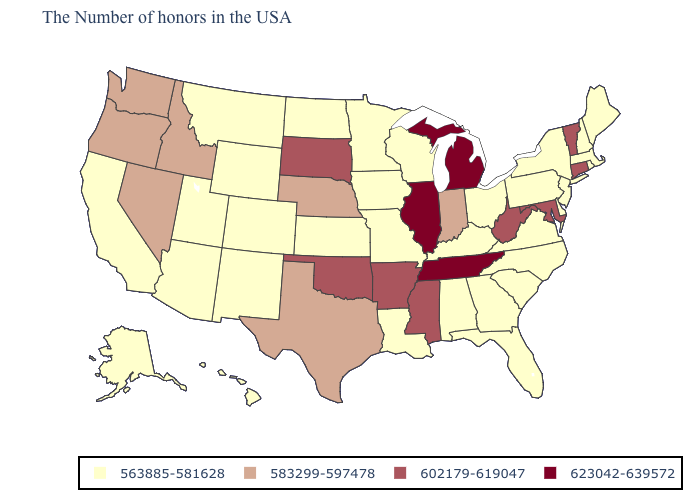Among the states that border Rhode Island , does Connecticut have the lowest value?
Give a very brief answer. No. What is the value of Michigan?
Give a very brief answer. 623042-639572. What is the value of Minnesota?
Quick response, please. 563885-581628. What is the value of South Dakota?
Answer briefly. 602179-619047. Name the states that have a value in the range 583299-597478?
Be succinct. Indiana, Nebraska, Texas, Idaho, Nevada, Washington, Oregon. Does Wyoming have the highest value in the West?
Keep it brief. No. Name the states that have a value in the range 623042-639572?
Give a very brief answer. Michigan, Tennessee, Illinois. Which states have the lowest value in the USA?
Short answer required. Maine, Massachusetts, Rhode Island, New Hampshire, New York, New Jersey, Delaware, Pennsylvania, Virginia, North Carolina, South Carolina, Ohio, Florida, Georgia, Kentucky, Alabama, Wisconsin, Louisiana, Missouri, Minnesota, Iowa, Kansas, North Dakota, Wyoming, Colorado, New Mexico, Utah, Montana, Arizona, California, Alaska, Hawaii. Which states have the highest value in the USA?
Short answer required. Michigan, Tennessee, Illinois. Name the states that have a value in the range 563885-581628?
Concise answer only. Maine, Massachusetts, Rhode Island, New Hampshire, New York, New Jersey, Delaware, Pennsylvania, Virginia, North Carolina, South Carolina, Ohio, Florida, Georgia, Kentucky, Alabama, Wisconsin, Louisiana, Missouri, Minnesota, Iowa, Kansas, North Dakota, Wyoming, Colorado, New Mexico, Utah, Montana, Arizona, California, Alaska, Hawaii. What is the value of Maryland?
Write a very short answer. 602179-619047. What is the value of Pennsylvania?
Keep it brief. 563885-581628. Does Oregon have the lowest value in the USA?
Write a very short answer. No. Among the states that border Louisiana , does Mississippi have the lowest value?
Quick response, please. No. Does the first symbol in the legend represent the smallest category?
Keep it brief. Yes. 